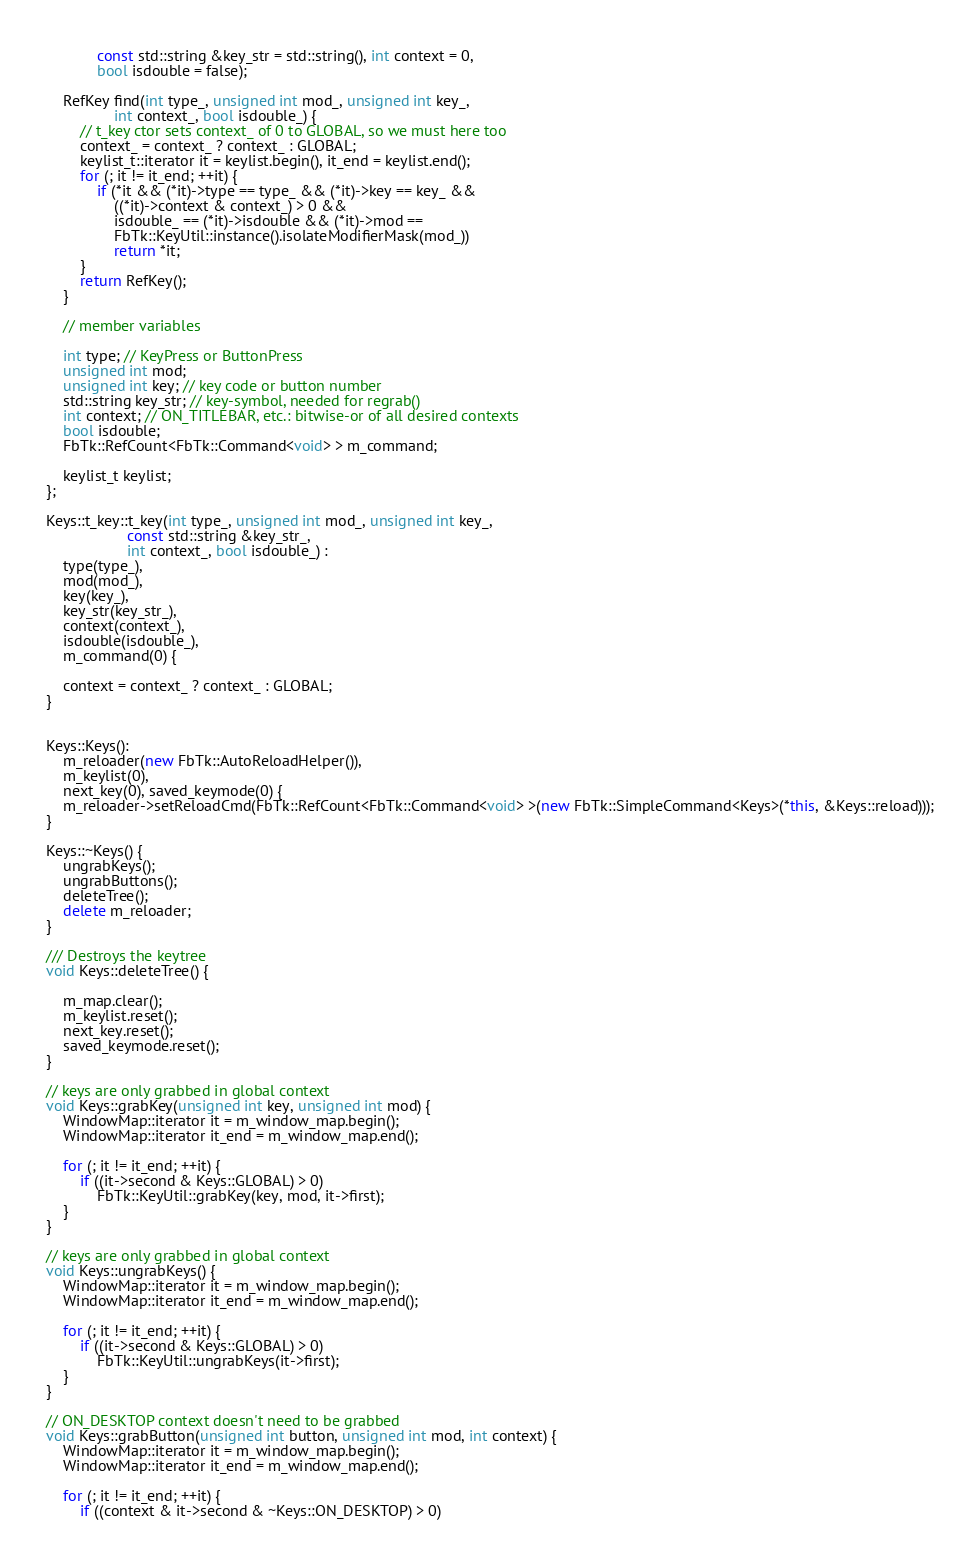<code> <loc_0><loc_0><loc_500><loc_500><_C++_>            const std::string &key_str = std::string(), int context = 0,
            bool isdouble = false);

    RefKey find(int type_, unsigned int mod_, unsigned int key_,
                int context_, bool isdouble_) {
        // t_key ctor sets context_ of 0 to GLOBAL, so we must here too
        context_ = context_ ? context_ : GLOBAL;
        keylist_t::iterator it = keylist.begin(), it_end = keylist.end();
        for (; it != it_end; ++it) {
            if (*it && (*it)->type == type_ && (*it)->key == key_ &&
                ((*it)->context & context_) > 0 &&
                isdouble_ == (*it)->isdouble && (*it)->mod ==
                FbTk::KeyUtil::instance().isolateModifierMask(mod_))
                return *it;
        }
        return RefKey();
    }

    // member variables

    int type; // KeyPress or ButtonPress
    unsigned int mod;
    unsigned int key; // key code or button number
    std::string key_str; // key-symbol, needed for regrab()
    int context; // ON_TITLEBAR, etc.: bitwise-or of all desired contexts
    bool isdouble;
    FbTk::RefCount<FbTk::Command<void> > m_command;

    keylist_t keylist;
};

Keys::t_key::t_key(int type_, unsigned int mod_, unsigned int key_,
                   const std::string &key_str_,
                   int context_, bool isdouble_) :
    type(type_),
    mod(mod_),
    key(key_),
    key_str(key_str_),
    context(context_),
    isdouble(isdouble_),
    m_command(0) {

    context = context_ ? context_ : GLOBAL;
}


Keys::Keys():
    m_reloader(new FbTk::AutoReloadHelper()),
    m_keylist(0),
    next_key(0), saved_keymode(0) {
    m_reloader->setReloadCmd(FbTk::RefCount<FbTk::Command<void> >(new FbTk::SimpleCommand<Keys>(*this, &Keys::reload)));
}

Keys::~Keys() {
    ungrabKeys();
    ungrabButtons();
    deleteTree();
    delete m_reloader;
}

/// Destroys the keytree
void Keys::deleteTree() {

    m_map.clear();
    m_keylist.reset();
    next_key.reset();
    saved_keymode.reset();
}

// keys are only grabbed in global context
void Keys::grabKey(unsigned int key, unsigned int mod) {
    WindowMap::iterator it = m_window_map.begin();
    WindowMap::iterator it_end = m_window_map.end();

    for (; it != it_end; ++it) {
        if ((it->second & Keys::GLOBAL) > 0)
            FbTk::KeyUtil::grabKey(key, mod, it->first);
    }
}

// keys are only grabbed in global context
void Keys::ungrabKeys() {
    WindowMap::iterator it = m_window_map.begin();
    WindowMap::iterator it_end = m_window_map.end();

    for (; it != it_end; ++it) {
        if ((it->second & Keys::GLOBAL) > 0)
            FbTk::KeyUtil::ungrabKeys(it->first);
    }
}

// ON_DESKTOP context doesn't need to be grabbed
void Keys::grabButton(unsigned int button, unsigned int mod, int context) {
    WindowMap::iterator it = m_window_map.begin();
    WindowMap::iterator it_end = m_window_map.end();

    for (; it != it_end; ++it) {
        if ((context & it->second & ~Keys::ON_DESKTOP) > 0)</code> 